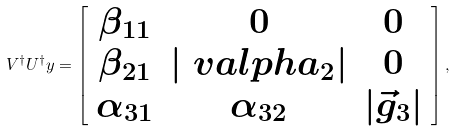Convert formula to latex. <formula><loc_0><loc_0><loc_500><loc_500>V ^ { \dagger } U ^ { \dagger } y = \left [ \begin{array} { c c c } \beta _ { 1 1 } & 0 & 0 \\ \beta _ { 2 1 } & | \ v a l p h a _ { 2 } | & 0 \\ \alpha _ { 3 1 } & \alpha _ { 3 2 } & | \vec { g } _ { 3 } | \end{array} \right ] ,</formula> 